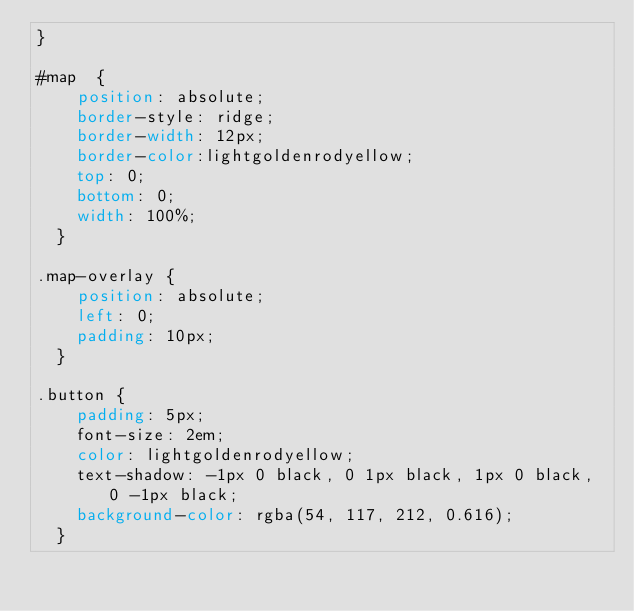<code> <loc_0><loc_0><loc_500><loc_500><_CSS_>}

#map  {
    position: absolute;
    border-style: ridge;
    border-width: 12px;
    border-color:lightgoldenrodyellow;
    top: 0;
    bottom: 0;
    width: 100%;
  }   

.map-overlay { 
    position: absolute; 
    left: 0; 
    padding: 10px;
  }

.button {
    padding: 5px;
    font-size: 2em; 
    color: lightgoldenrodyellow;
    text-shadow: -1px 0 black, 0 1px black, 1px 0 black, 0 -1px black;
    background-color: rgba(54, 117, 212, 0.616);
  }

</code> 